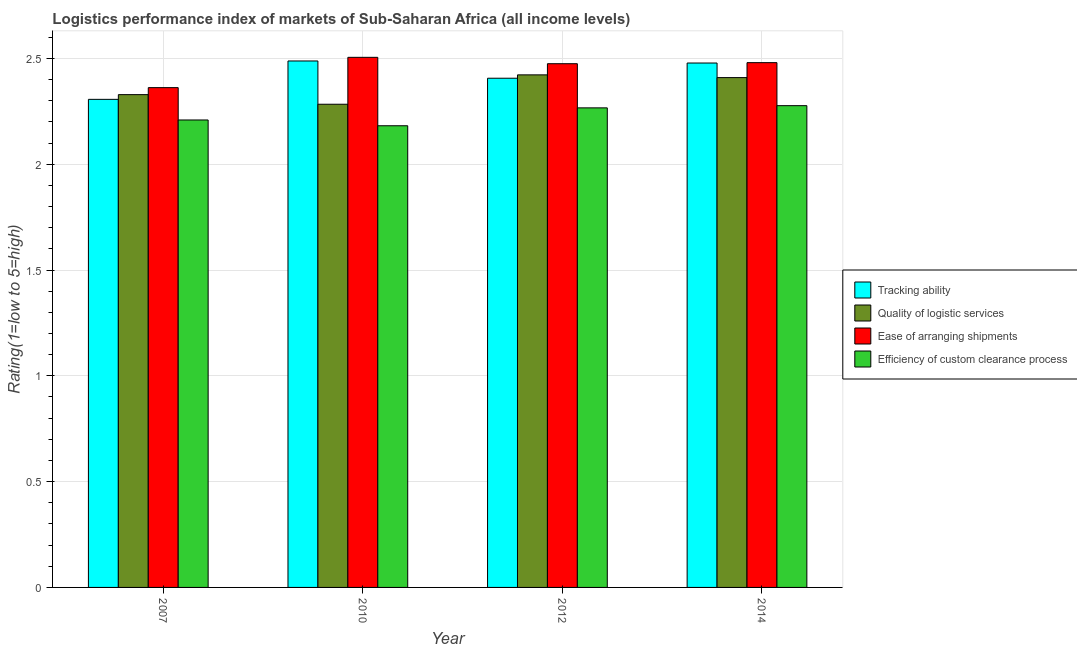How many groups of bars are there?
Offer a very short reply. 4. Are the number of bars on each tick of the X-axis equal?
Make the answer very short. Yes. How many bars are there on the 3rd tick from the left?
Offer a very short reply. 4. What is the lpi rating of tracking ability in 2010?
Offer a very short reply. 2.49. Across all years, what is the maximum lpi rating of ease of arranging shipments?
Ensure brevity in your answer.  2.5. Across all years, what is the minimum lpi rating of efficiency of custom clearance process?
Offer a terse response. 2.18. What is the total lpi rating of ease of arranging shipments in the graph?
Make the answer very short. 9.82. What is the difference between the lpi rating of efficiency of custom clearance process in 2012 and that in 2014?
Your answer should be compact. -0.01. What is the difference between the lpi rating of efficiency of custom clearance process in 2014 and the lpi rating of tracking ability in 2010?
Provide a succinct answer. 0.09. What is the average lpi rating of ease of arranging shipments per year?
Offer a terse response. 2.46. In how many years, is the lpi rating of quality of logistic services greater than 2.5?
Your answer should be compact. 0. What is the ratio of the lpi rating of quality of logistic services in 2010 to that in 2012?
Offer a very short reply. 0.94. Is the lpi rating of quality of logistic services in 2007 less than that in 2010?
Your answer should be very brief. No. What is the difference between the highest and the second highest lpi rating of ease of arranging shipments?
Keep it short and to the point. 0.03. What is the difference between the highest and the lowest lpi rating of ease of arranging shipments?
Offer a very short reply. 0.14. In how many years, is the lpi rating of ease of arranging shipments greater than the average lpi rating of ease of arranging shipments taken over all years?
Provide a succinct answer. 3. Is the sum of the lpi rating of ease of arranging shipments in 2010 and 2012 greater than the maximum lpi rating of tracking ability across all years?
Keep it short and to the point. Yes. Is it the case that in every year, the sum of the lpi rating of quality of logistic services and lpi rating of efficiency of custom clearance process is greater than the sum of lpi rating of tracking ability and lpi rating of ease of arranging shipments?
Offer a terse response. No. What does the 2nd bar from the left in 2007 represents?
Your answer should be compact. Quality of logistic services. What does the 4th bar from the right in 2007 represents?
Your answer should be compact. Tracking ability. Are all the bars in the graph horizontal?
Make the answer very short. No. What is the difference between two consecutive major ticks on the Y-axis?
Make the answer very short. 0.5. Are the values on the major ticks of Y-axis written in scientific E-notation?
Ensure brevity in your answer.  No. Where does the legend appear in the graph?
Give a very brief answer. Center right. What is the title of the graph?
Your response must be concise. Logistics performance index of markets of Sub-Saharan Africa (all income levels). What is the label or title of the Y-axis?
Ensure brevity in your answer.  Rating(1=low to 5=high). What is the Rating(1=low to 5=high) in Tracking ability in 2007?
Your answer should be compact. 2.31. What is the Rating(1=low to 5=high) of Quality of logistic services in 2007?
Offer a terse response. 2.33. What is the Rating(1=low to 5=high) of Ease of arranging shipments in 2007?
Offer a very short reply. 2.36. What is the Rating(1=low to 5=high) in Efficiency of custom clearance process in 2007?
Give a very brief answer. 2.21. What is the Rating(1=low to 5=high) of Tracking ability in 2010?
Your answer should be very brief. 2.49. What is the Rating(1=low to 5=high) in Quality of logistic services in 2010?
Offer a very short reply. 2.28. What is the Rating(1=low to 5=high) of Ease of arranging shipments in 2010?
Give a very brief answer. 2.5. What is the Rating(1=low to 5=high) in Efficiency of custom clearance process in 2010?
Provide a succinct answer. 2.18. What is the Rating(1=low to 5=high) in Tracking ability in 2012?
Make the answer very short. 2.41. What is the Rating(1=low to 5=high) in Quality of logistic services in 2012?
Your answer should be compact. 2.42. What is the Rating(1=low to 5=high) of Ease of arranging shipments in 2012?
Ensure brevity in your answer.  2.47. What is the Rating(1=low to 5=high) of Efficiency of custom clearance process in 2012?
Ensure brevity in your answer.  2.27. What is the Rating(1=low to 5=high) in Tracking ability in 2014?
Keep it short and to the point. 2.48. What is the Rating(1=low to 5=high) in Quality of logistic services in 2014?
Your answer should be compact. 2.41. What is the Rating(1=low to 5=high) of Ease of arranging shipments in 2014?
Provide a succinct answer. 2.48. What is the Rating(1=low to 5=high) in Efficiency of custom clearance process in 2014?
Keep it short and to the point. 2.28. Across all years, what is the maximum Rating(1=low to 5=high) of Tracking ability?
Ensure brevity in your answer.  2.49. Across all years, what is the maximum Rating(1=low to 5=high) of Quality of logistic services?
Offer a terse response. 2.42. Across all years, what is the maximum Rating(1=low to 5=high) of Ease of arranging shipments?
Give a very brief answer. 2.5. Across all years, what is the maximum Rating(1=low to 5=high) in Efficiency of custom clearance process?
Your answer should be very brief. 2.28. Across all years, what is the minimum Rating(1=low to 5=high) in Tracking ability?
Ensure brevity in your answer.  2.31. Across all years, what is the minimum Rating(1=low to 5=high) of Quality of logistic services?
Make the answer very short. 2.28. Across all years, what is the minimum Rating(1=low to 5=high) of Ease of arranging shipments?
Your response must be concise. 2.36. Across all years, what is the minimum Rating(1=low to 5=high) of Efficiency of custom clearance process?
Provide a short and direct response. 2.18. What is the total Rating(1=low to 5=high) in Tracking ability in the graph?
Make the answer very short. 9.68. What is the total Rating(1=low to 5=high) in Quality of logistic services in the graph?
Your response must be concise. 9.44. What is the total Rating(1=low to 5=high) in Ease of arranging shipments in the graph?
Your answer should be very brief. 9.82. What is the total Rating(1=low to 5=high) in Efficiency of custom clearance process in the graph?
Make the answer very short. 8.93. What is the difference between the Rating(1=low to 5=high) in Tracking ability in 2007 and that in 2010?
Ensure brevity in your answer.  -0.18. What is the difference between the Rating(1=low to 5=high) of Quality of logistic services in 2007 and that in 2010?
Your response must be concise. 0.05. What is the difference between the Rating(1=low to 5=high) of Ease of arranging shipments in 2007 and that in 2010?
Your answer should be very brief. -0.14. What is the difference between the Rating(1=low to 5=high) in Efficiency of custom clearance process in 2007 and that in 2010?
Keep it short and to the point. 0.03. What is the difference between the Rating(1=low to 5=high) of Tracking ability in 2007 and that in 2012?
Provide a short and direct response. -0.1. What is the difference between the Rating(1=low to 5=high) of Quality of logistic services in 2007 and that in 2012?
Offer a very short reply. -0.09. What is the difference between the Rating(1=low to 5=high) in Ease of arranging shipments in 2007 and that in 2012?
Your response must be concise. -0.11. What is the difference between the Rating(1=low to 5=high) of Efficiency of custom clearance process in 2007 and that in 2012?
Ensure brevity in your answer.  -0.06. What is the difference between the Rating(1=low to 5=high) in Tracking ability in 2007 and that in 2014?
Keep it short and to the point. -0.17. What is the difference between the Rating(1=low to 5=high) of Quality of logistic services in 2007 and that in 2014?
Provide a succinct answer. -0.08. What is the difference between the Rating(1=low to 5=high) of Ease of arranging shipments in 2007 and that in 2014?
Keep it short and to the point. -0.12. What is the difference between the Rating(1=low to 5=high) of Efficiency of custom clearance process in 2007 and that in 2014?
Keep it short and to the point. -0.07. What is the difference between the Rating(1=low to 5=high) in Tracking ability in 2010 and that in 2012?
Provide a short and direct response. 0.08. What is the difference between the Rating(1=low to 5=high) of Quality of logistic services in 2010 and that in 2012?
Offer a terse response. -0.14. What is the difference between the Rating(1=low to 5=high) in Ease of arranging shipments in 2010 and that in 2012?
Provide a short and direct response. 0.03. What is the difference between the Rating(1=low to 5=high) of Efficiency of custom clearance process in 2010 and that in 2012?
Provide a succinct answer. -0.08. What is the difference between the Rating(1=low to 5=high) in Tracking ability in 2010 and that in 2014?
Keep it short and to the point. 0.01. What is the difference between the Rating(1=low to 5=high) in Quality of logistic services in 2010 and that in 2014?
Provide a short and direct response. -0.13. What is the difference between the Rating(1=low to 5=high) of Ease of arranging shipments in 2010 and that in 2014?
Provide a short and direct response. 0.03. What is the difference between the Rating(1=low to 5=high) in Efficiency of custom clearance process in 2010 and that in 2014?
Your response must be concise. -0.09. What is the difference between the Rating(1=low to 5=high) of Tracking ability in 2012 and that in 2014?
Provide a short and direct response. -0.07. What is the difference between the Rating(1=low to 5=high) of Quality of logistic services in 2012 and that in 2014?
Provide a succinct answer. 0.01. What is the difference between the Rating(1=low to 5=high) in Ease of arranging shipments in 2012 and that in 2014?
Give a very brief answer. -0.01. What is the difference between the Rating(1=low to 5=high) of Efficiency of custom clearance process in 2012 and that in 2014?
Give a very brief answer. -0.01. What is the difference between the Rating(1=low to 5=high) of Tracking ability in 2007 and the Rating(1=low to 5=high) of Quality of logistic services in 2010?
Your response must be concise. 0.02. What is the difference between the Rating(1=low to 5=high) in Tracking ability in 2007 and the Rating(1=low to 5=high) in Ease of arranging shipments in 2010?
Your answer should be compact. -0.2. What is the difference between the Rating(1=low to 5=high) in Tracking ability in 2007 and the Rating(1=low to 5=high) in Efficiency of custom clearance process in 2010?
Offer a very short reply. 0.12. What is the difference between the Rating(1=low to 5=high) in Quality of logistic services in 2007 and the Rating(1=low to 5=high) in Ease of arranging shipments in 2010?
Ensure brevity in your answer.  -0.18. What is the difference between the Rating(1=low to 5=high) of Quality of logistic services in 2007 and the Rating(1=low to 5=high) of Efficiency of custom clearance process in 2010?
Keep it short and to the point. 0.15. What is the difference between the Rating(1=low to 5=high) of Ease of arranging shipments in 2007 and the Rating(1=low to 5=high) of Efficiency of custom clearance process in 2010?
Provide a short and direct response. 0.18. What is the difference between the Rating(1=low to 5=high) in Tracking ability in 2007 and the Rating(1=low to 5=high) in Quality of logistic services in 2012?
Make the answer very short. -0.12. What is the difference between the Rating(1=low to 5=high) in Tracking ability in 2007 and the Rating(1=low to 5=high) in Ease of arranging shipments in 2012?
Your response must be concise. -0.17. What is the difference between the Rating(1=low to 5=high) of Tracking ability in 2007 and the Rating(1=low to 5=high) of Efficiency of custom clearance process in 2012?
Make the answer very short. 0.04. What is the difference between the Rating(1=low to 5=high) in Quality of logistic services in 2007 and the Rating(1=low to 5=high) in Ease of arranging shipments in 2012?
Your response must be concise. -0.15. What is the difference between the Rating(1=low to 5=high) in Quality of logistic services in 2007 and the Rating(1=low to 5=high) in Efficiency of custom clearance process in 2012?
Provide a short and direct response. 0.06. What is the difference between the Rating(1=low to 5=high) of Ease of arranging shipments in 2007 and the Rating(1=low to 5=high) of Efficiency of custom clearance process in 2012?
Offer a very short reply. 0.1. What is the difference between the Rating(1=low to 5=high) of Tracking ability in 2007 and the Rating(1=low to 5=high) of Quality of logistic services in 2014?
Keep it short and to the point. -0.1. What is the difference between the Rating(1=low to 5=high) in Tracking ability in 2007 and the Rating(1=low to 5=high) in Ease of arranging shipments in 2014?
Ensure brevity in your answer.  -0.17. What is the difference between the Rating(1=low to 5=high) of Tracking ability in 2007 and the Rating(1=low to 5=high) of Efficiency of custom clearance process in 2014?
Give a very brief answer. 0.03. What is the difference between the Rating(1=low to 5=high) in Quality of logistic services in 2007 and the Rating(1=low to 5=high) in Ease of arranging shipments in 2014?
Your answer should be very brief. -0.15. What is the difference between the Rating(1=low to 5=high) in Quality of logistic services in 2007 and the Rating(1=low to 5=high) in Efficiency of custom clearance process in 2014?
Provide a succinct answer. 0.05. What is the difference between the Rating(1=low to 5=high) of Ease of arranging shipments in 2007 and the Rating(1=low to 5=high) of Efficiency of custom clearance process in 2014?
Your answer should be very brief. 0.09. What is the difference between the Rating(1=low to 5=high) of Tracking ability in 2010 and the Rating(1=low to 5=high) of Quality of logistic services in 2012?
Provide a short and direct response. 0.07. What is the difference between the Rating(1=low to 5=high) in Tracking ability in 2010 and the Rating(1=low to 5=high) in Ease of arranging shipments in 2012?
Your response must be concise. 0.01. What is the difference between the Rating(1=low to 5=high) in Tracking ability in 2010 and the Rating(1=low to 5=high) in Efficiency of custom clearance process in 2012?
Make the answer very short. 0.22. What is the difference between the Rating(1=low to 5=high) in Quality of logistic services in 2010 and the Rating(1=low to 5=high) in Ease of arranging shipments in 2012?
Your answer should be compact. -0.19. What is the difference between the Rating(1=low to 5=high) of Quality of logistic services in 2010 and the Rating(1=low to 5=high) of Efficiency of custom clearance process in 2012?
Keep it short and to the point. 0.02. What is the difference between the Rating(1=low to 5=high) in Ease of arranging shipments in 2010 and the Rating(1=low to 5=high) in Efficiency of custom clearance process in 2012?
Your response must be concise. 0.24. What is the difference between the Rating(1=low to 5=high) of Tracking ability in 2010 and the Rating(1=low to 5=high) of Quality of logistic services in 2014?
Make the answer very short. 0.08. What is the difference between the Rating(1=low to 5=high) of Tracking ability in 2010 and the Rating(1=low to 5=high) of Ease of arranging shipments in 2014?
Offer a very short reply. 0.01. What is the difference between the Rating(1=low to 5=high) in Tracking ability in 2010 and the Rating(1=low to 5=high) in Efficiency of custom clearance process in 2014?
Give a very brief answer. 0.21. What is the difference between the Rating(1=low to 5=high) of Quality of logistic services in 2010 and the Rating(1=low to 5=high) of Ease of arranging shipments in 2014?
Provide a short and direct response. -0.2. What is the difference between the Rating(1=low to 5=high) of Quality of logistic services in 2010 and the Rating(1=low to 5=high) of Efficiency of custom clearance process in 2014?
Keep it short and to the point. 0.01. What is the difference between the Rating(1=low to 5=high) of Ease of arranging shipments in 2010 and the Rating(1=low to 5=high) of Efficiency of custom clearance process in 2014?
Keep it short and to the point. 0.23. What is the difference between the Rating(1=low to 5=high) of Tracking ability in 2012 and the Rating(1=low to 5=high) of Quality of logistic services in 2014?
Your response must be concise. -0. What is the difference between the Rating(1=low to 5=high) in Tracking ability in 2012 and the Rating(1=low to 5=high) in Ease of arranging shipments in 2014?
Your answer should be very brief. -0.07. What is the difference between the Rating(1=low to 5=high) of Tracking ability in 2012 and the Rating(1=low to 5=high) of Efficiency of custom clearance process in 2014?
Provide a succinct answer. 0.13. What is the difference between the Rating(1=low to 5=high) of Quality of logistic services in 2012 and the Rating(1=low to 5=high) of Ease of arranging shipments in 2014?
Provide a succinct answer. -0.06. What is the difference between the Rating(1=low to 5=high) in Quality of logistic services in 2012 and the Rating(1=low to 5=high) in Efficiency of custom clearance process in 2014?
Provide a short and direct response. 0.15. What is the difference between the Rating(1=low to 5=high) of Ease of arranging shipments in 2012 and the Rating(1=low to 5=high) of Efficiency of custom clearance process in 2014?
Give a very brief answer. 0.2. What is the average Rating(1=low to 5=high) of Tracking ability per year?
Offer a terse response. 2.42. What is the average Rating(1=low to 5=high) of Quality of logistic services per year?
Your answer should be compact. 2.36. What is the average Rating(1=low to 5=high) in Ease of arranging shipments per year?
Offer a very short reply. 2.46. What is the average Rating(1=low to 5=high) in Efficiency of custom clearance process per year?
Provide a succinct answer. 2.23. In the year 2007, what is the difference between the Rating(1=low to 5=high) of Tracking ability and Rating(1=low to 5=high) of Quality of logistic services?
Offer a terse response. -0.02. In the year 2007, what is the difference between the Rating(1=low to 5=high) of Tracking ability and Rating(1=low to 5=high) of Ease of arranging shipments?
Keep it short and to the point. -0.06. In the year 2007, what is the difference between the Rating(1=low to 5=high) in Tracking ability and Rating(1=low to 5=high) in Efficiency of custom clearance process?
Offer a terse response. 0.1. In the year 2007, what is the difference between the Rating(1=low to 5=high) of Quality of logistic services and Rating(1=low to 5=high) of Ease of arranging shipments?
Your answer should be compact. -0.03. In the year 2007, what is the difference between the Rating(1=low to 5=high) in Quality of logistic services and Rating(1=low to 5=high) in Efficiency of custom clearance process?
Your answer should be very brief. 0.12. In the year 2007, what is the difference between the Rating(1=low to 5=high) of Ease of arranging shipments and Rating(1=low to 5=high) of Efficiency of custom clearance process?
Your answer should be compact. 0.15. In the year 2010, what is the difference between the Rating(1=low to 5=high) in Tracking ability and Rating(1=low to 5=high) in Quality of logistic services?
Offer a very short reply. 0.2. In the year 2010, what is the difference between the Rating(1=low to 5=high) of Tracking ability and Rating(1=low to 5=high) of Ease of arranging shipments?
Ensure brevity in your answer.  -0.02. In the year 2010, what is the difference between the Rating(1=low to 5=high) in Tracking ability and Rating(1=low to 5=high) in Efficiency of custom clearance process?
Offer a very short reply. 0.31. In the year 2010, what is the difference between the Rating(1=low to 5=high) of Quality of logistic services and Rating(1=low to 5=high) of Ease of arranging shipments?
Provide a succinct answer. -0.22. In the year 2010, what is the difference between the Rating(1=low to 5=high) of Quality of logistic services and Rating(1=low to 5=high) of Efficiency of custom clearance process?
Offer a terse response. 0.1. In the year 2010, what is the difference between the Rating(1=low to 5=high) in Ease of arranging shipments and Rating(1=low to 5=high) in Efficiency of custom clearance process?
Give a very brief answer. 0.32. In the year 2012, what is the difference between the Rating(1=low to 5=high) of Tracking ability and Rating(1=low to 5=high) of Quality of logistic services?
Keep it short and to the point. -0.02. In the year 2012, what is the difference between the Rating(1=low to 5=high) in Tracking ability and Rating(1=low to 5=high) in Ease of arranging shipments?
Ensure brevity in your answer.  -0.07. In the year 2012, what is the difference between the Rating(1=low to 5=high) in Tracking ability and Rating(1=low to 5=high) in Efficiency of custom clearance process?
Keep it short and to the point. 0.14. In the year 2012, what is the difference between the Rating(1=low to 5=high) of Quality of logistic services and Rating(1=low to 5=high) of Ease of arranging shipments?
Ensure brevity in your answer.  -0.05. In the year 2012, what is the difference between the Rating(1=low to 5=high) of Quality of logistic services and Rating(1=low to 5=high) of Efficiency of custom clearance process?
Provide a short and direct response. 0.16. In the year 2012, what is the difference between the Rating(1=low to 5=high) of Ease of arranging shipments and Rating(1=low to 5=high) of Efficiency of custom clearance process?
Your answer should be very brief. 0.21. In the year 2014, what is the difference between the Rating(1=low to 5=high) in Tracking ability and Rating(1=low to 5=high) in Quality of logistic services?
Offer a very short reply. 0.07. In the year 2014, what is the difference between the Rating(1=low to 5=high) of Tracking ability and Rating(1=low to 5=high) of Ease of arranging shipments?
Your answer should be very brief. -0. In the year 2014, what is the difference between the Rating(1=low to 5=high) in Tracking ability and Rating(1=low to 5=high) in Efficiency of custom clearance process?
Make the answer very short. 0.2. In the year 2014, what is the difference between the Rating(1=low to 5=high) in Quality of logistic services and Rating(1=low to 5=high) in Ease of arranging shipments?
Provide a short and direct response. -0.07. In the year 2014, what is the difference between the Rating(1=low to 5=high) in Quality of logistic services and Rating(1=low to 5=high) in Efficiency of custom clearance process?
Provide a short and direct response. 0.13. In the year 2014, what is the difference between the Rating(1=low to 5=high) in Ease of arranging shipments and Rating(1=low to 5=high) in Efficiency of custom clearance process?
Your answer should be very brief. 0.2. What is the ratio of the Rating(1=low to 5=high) in Tracking ability in 2007 to that in 2010?
Your response must be concise. 0.93. What is the ratio of the Rating(1=low to 5=high) of Quality of logistic services in 2007 to that in 2010?
Your answer should be compact. 1.02. What is the ratio of the Rating(1=low to 5=high) in Ease of arranging shipments in 2007 to that in 2010?
Provide a short and direct response. 0.94. What is the ratio of the Rating(1=low to 5=high) of Efficiency of custom clearance process in 2007 to that in 2010?
Offer a very short reply. 1.01. What is the ratio of the Rating(1=low to 5=high) in Tracking ability in 2007 to that in 2012?
Your response must be concise. 0.96. What is the ratio of the Rating(1=low to 5=high) of Quality of logistic services in 2007 to that in 2012?
Keep it short and to the point. 0.96. What is the ratio of the Rating(1=low to 5=high) of Ease of arranging shipments in 2007 to that in 2012?
Provide a succinct answer. 0.95. What is the ratio of the Rating(1=low to 5=high) of Efficiency of custom clearance process in 2007 to that in 2012?
Your response must be concise. 0.97. What is the ratio of the Rating(1=low to 5=high) of Tracking ability in 2007 to that in 2014?
Your answer should be compact. 0.93. What is the ratio of the Rating(1=low to 5=high) in Quality of logistic services in 2007 to that in 2014?
Give a very brief answer. 0.97. What is the ratio of the Rating(1=low to 5=high) in Efficiency of custom clearance process in 2007 to that in 2014?
Keep it short and to the point. 0.97. What is the ratio of the Rating(1=low to 5=high) in Tracking ability in 2010 to that in 2012?
Provide a short and direct response. 1.03. What is the ratio of the Rating(1=low to 5=high) of Quality of logistic services in 2010 to that in 2012?
Provide a short and direct response. 0.94. What is the ratio of the Rating(1=low to 5=high) in Ease of arranging shipments in 2010 to that in 2012?
Offer a terse response. 1.01. What is the ratio of the Rating(1=low to 5=high) of Efficiency of custom clearance process in 2010 to that in 2012?
Offer a terse response. 0.96. What is the ratio of the Rating(1=low to 5=high) of Quality of logistic services in 2010 to that in 2014?
Offer a very short reply. 0.95. What is the ratio of the Rating(1=low to 5=high) in Efficiency of custom clearance process in 2010 to that in 2014?
Keep it short and to the point. 0.96. What is the ratio of the Rating(1=low to 5=high) of Quality of logistic services in 2012 to that in 2014?
Make the answer very short. 1.01. What is the difference between the highest and the second highest Rating(1=low to 5=high) of Tracking ability?
Make the answer very short. 0.01. What is the difference between the highest and the second highest Rating(1=low to 5=high) of Quality of logistic services?
Make the answer very short. 0.01. What is the difference between the highest and the second highest Rating(1=low to 5=high) of Ease of arranging shipments?
Offer a terse response. 0.03. What is the difference between the highest and the second highest Rating(1=low to 5=high) of Efficiency of custom clearance process?
Make the answer very short. 0.01. What is the difference between the highest and the lowest Rating(1=low to 5=high) of Tracking ability?
Make the answer very short. 0.18. What is the difference between the highest and the lowest Rating(1=low to 5=high) of Quality of logistic services?
Make the answer very short. 0.14. What is the difference between the highest and the lowest Rating(1=low to 5=high) in Ease of arranging shipments?
Provide a short and direct response. 0.14. What is the difference between the highest and the lowest Rating(1=low to 5=high) in Efficiency of custom clearance process?
Ensure brevity in your answer.  0.09. 